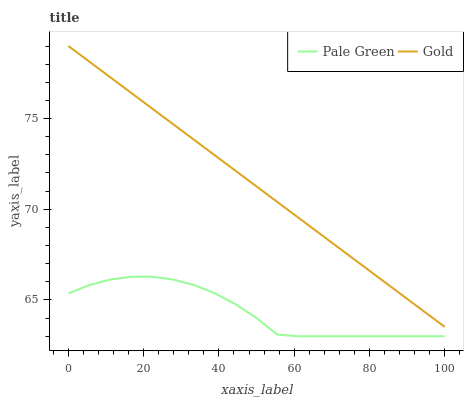Does Pale Green have the minimum area under the curve?
Answer yes or no. Yes. Does Gold have the maximum area under the curve?
Answer yes or no. Yes. Does Gold have the minimum area under the curve?
Answer yes or no. No. Is Gold the smoothest?
Answer yes or no. Yes. Is Pale Green the roughest?
Answer yes or no. Yes. Is Gold the roughest?
Answer yes or no. No. Does Gold have the lowest value?
Answer yes or no. No. Is Pale Green less than Gold?
Answer yes or no. Yes. Is Gold greater than Pale Green?
Answer yes or no. Yes. Does Pale Green intersect Gold?
Answer yes or no. No. 